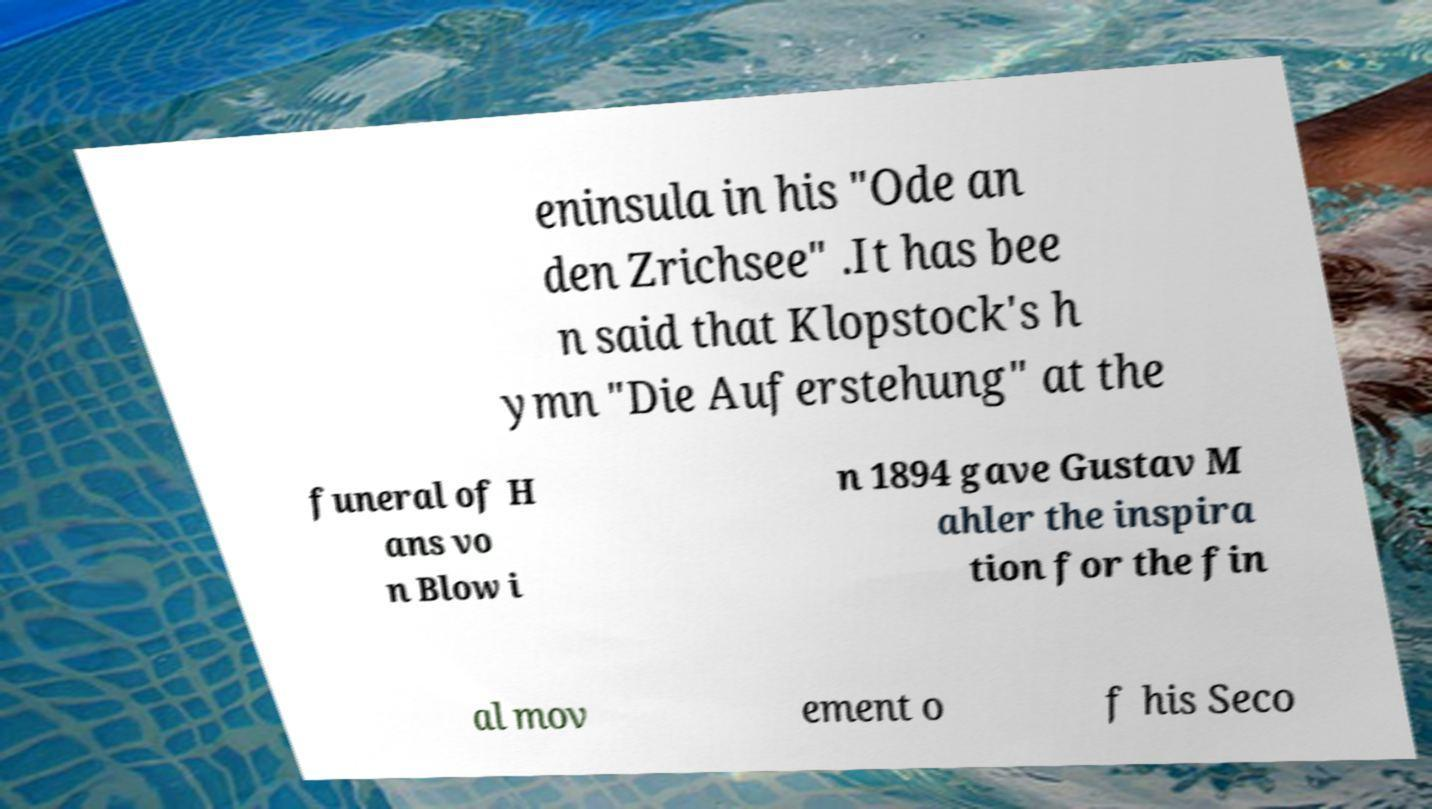I need the written content from this picture converted into text. Can you do that? eninsula in his "Ode an den Zrichsee" .It has bee n said that Klopstock's h ymn "Die Auferstehung" at the funeral of H ans vo n Blow i n 1894 gave Gustav M ahler the inspira tion for the fin al mov ement o f his Seco 